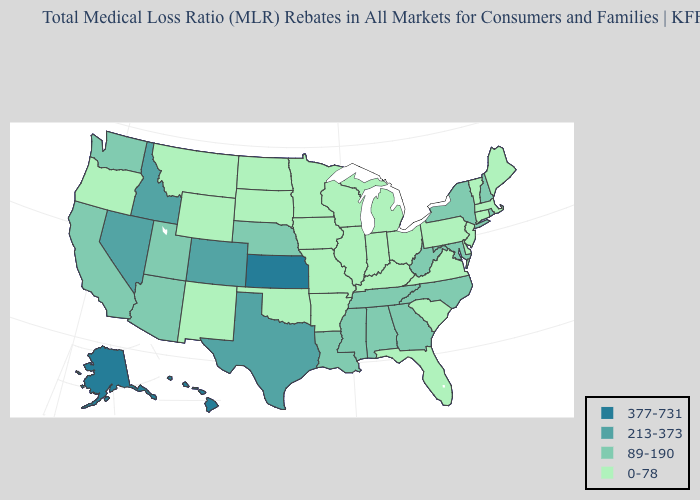Does the map have missing data?
Write a very short answer. No. Name the states that have a value in the range 213-373?
Concise answer only. Colorado, Idaho, Nevada, Texas. Does the first symbol in the legend represent the smallest category?
Write a very short answer. No. Name the states that have a value in the range 213-373?
Answer briefly. Colorado, Idaho, Nevada, Texas. Name the states that have a value in the range 89-190?
Keep it brief. Alabama, Arizona, California, Georgia, Louisiana, Maryland, Mississippi, Nebraska, New Hampshire, New York, North Carolina, Rhode Island, Tennessee, Utah, Washington, West Virginia. Is the legend a continuous bar?
Be succinct. No. What is the lowest value in the MidWest?
Quick response, please. 0-78. Name the states that have a value in the range 213-373?
Concise answer only. Colorado, Idaho, Nevada, Texas. What is the lowest value in states that border Iowa?
Keep it brief. 0-78. Which states hav the highest value in the Northeast?
Quick response, please. New Hampshire, New York, Rhode Island. What is the value of New York?
Short answer required. 89-190. What is the value of Connecticut?
Give a very brief answer. 0-78. What is the lowest value in states that border Kansas?
Keep it brief. 0-78. Does New Mexico have a higher value than Delaware?
Short answer required. No. Does Connecticut have the lowest value in the USA?
Be succinct. Yes. 